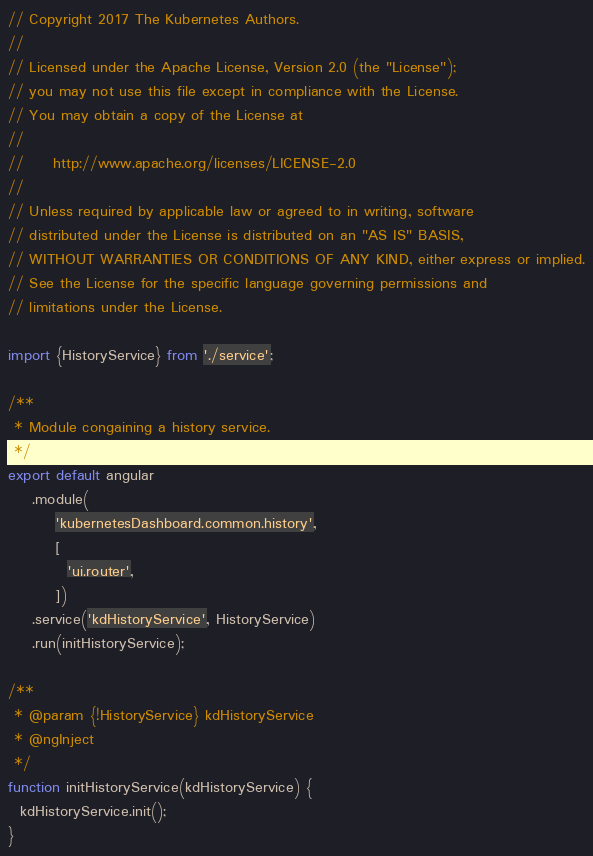Convert code to text. <code><loc_0><loc_0><loc_500><loc_500><_JavaScript_>// Copyright 2017 The Kubernetes Authors.
//
// Licensed under the Apache License, Version 2.0 (the "License");
// you may not use this file except in compliance with the License.
// You may obtain a copy of the License at
//
//     http://www.apache.org/licenses/LICENSE-2.0
//
// Unless required by applicable law or agreed to in writing, software
// distributed under the License is distributed on an "AS IS" BASIS,
// WITHOUT WARRANTIES OR CONDITIONS OF ANY KIND, either express or implied.
// See the License for the specific language governing permissions and
// limitations under the License.

import {HistoryService} from './service';

/**
 * Module congaining a history service.
 */
export default angular
    .module(
        'kubernetesDashboard.common.history',
        [
          'ui.router',
        ])
    .service('kdHistoryService', HistoryService)
    .run(initHistoryService);

/**
 * @param {!HistoryService} kdHistoryService
 * @ngInject
 */
function initHistoryService(kdHistoryService) {
  kdHistoryService.init();
}
</code> 